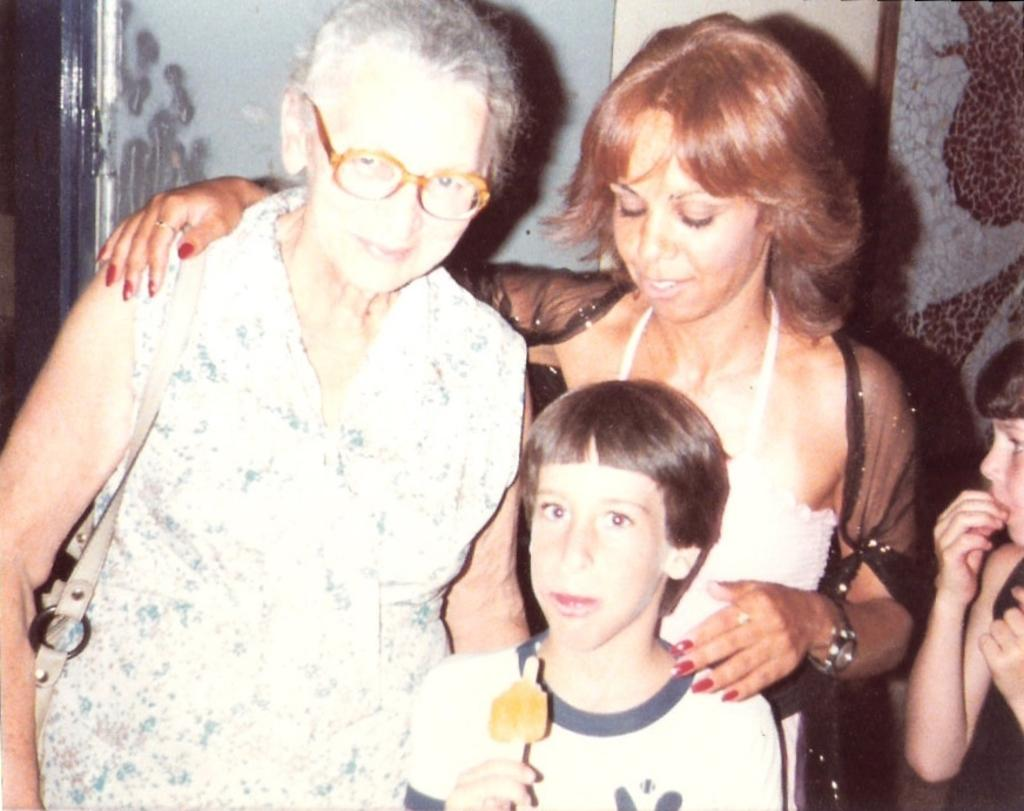How many people are in the image? There are people in the image, but the exact number is not specified. What is the person holding in the image? One person is holding an object in the image. What can be seen in the background of the image? There is a wall visible in the image. What is the committee's opinion on the balance of the object in the image? There is no mention of a committee or balance in the image, so it's not possible to answer that question. 